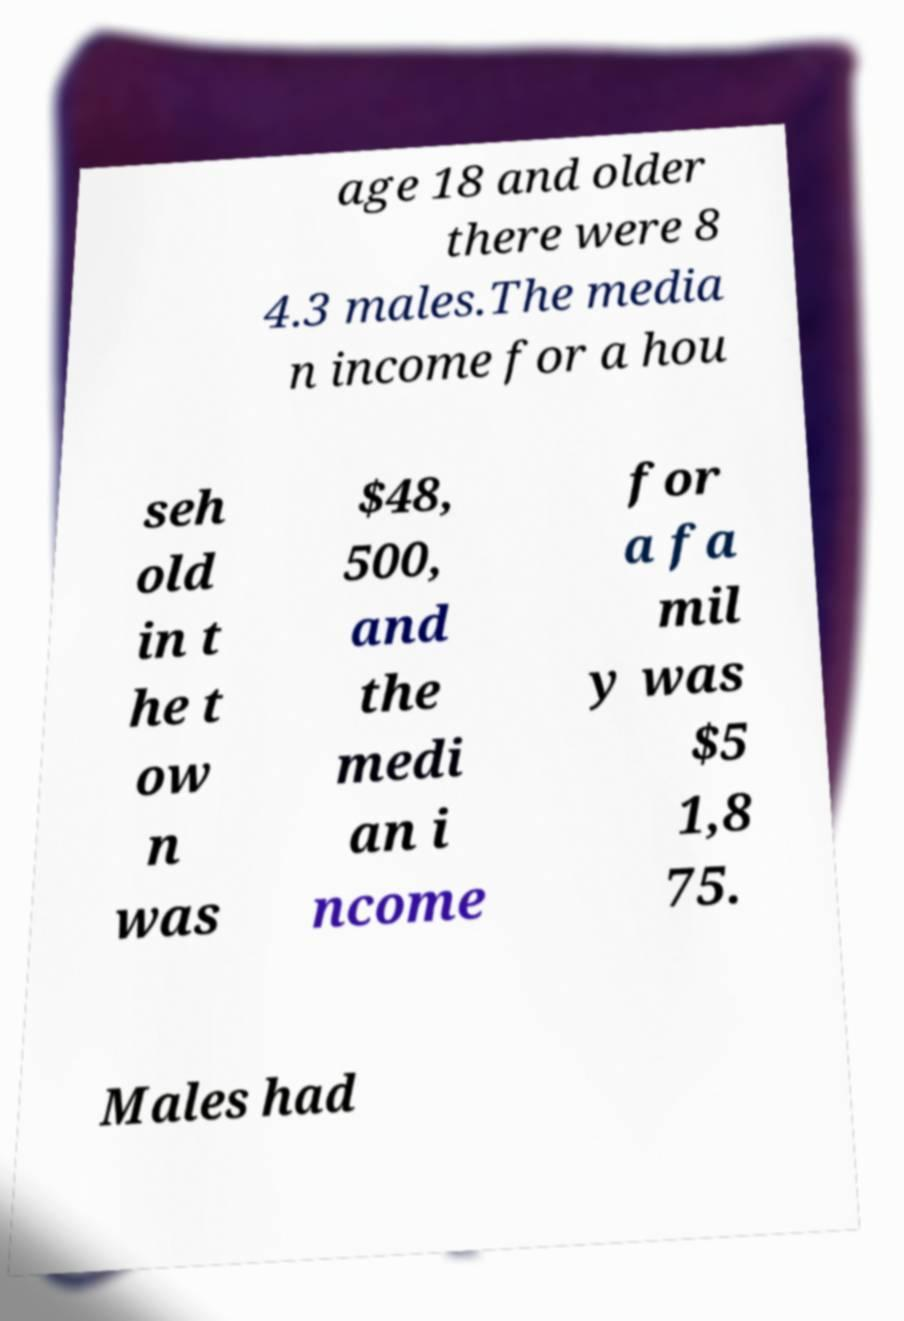Can you read and provide the text displayed in the image?This photo seems to have some interesting text. Can you extract and type it out for me? age 18 and older there were 8 4.3 males.The media n income for a hou seh old in t he t ow n was $48, 500, and the medi an i ncome for a fa mil y was $5 1,8 75. Males had 